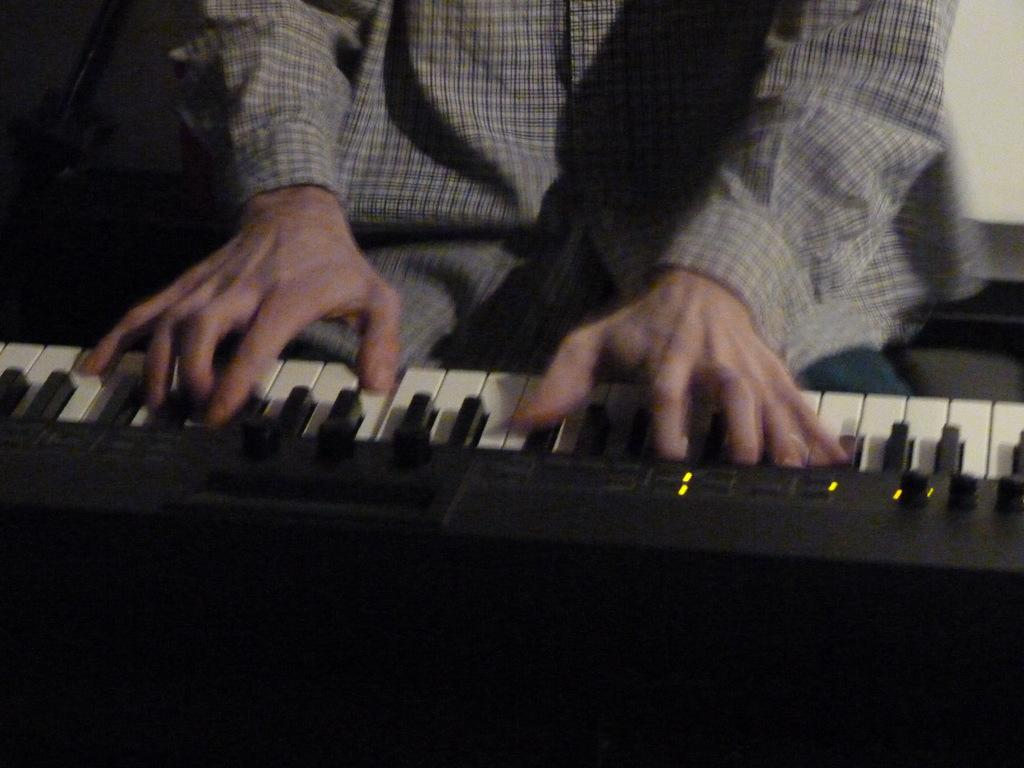What is the main subject of the image? There is a person in the image. What is the person doing in the image? The person is playing a piano. What type of whistle can be heard in the image? There is no whistle present in the image; it features a person playing a piano. What is the value of the piano cover in the image? There is no piano cover present in the image, so it is not possible to determine its value. 